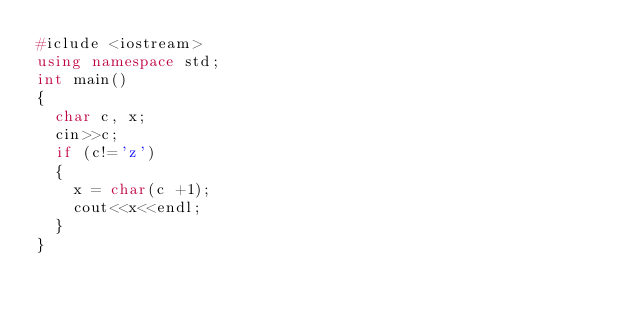<code> <loc_0><loc_0><loc_500><loc_500><_C++_>#iclude <iostream>
using namespace std;
int main()
{
  char c, x;
  cin>>c;
  if (c!='z')
  {
    x = char(c +1);
    cout<<x<<endl;
  }
}</code> 